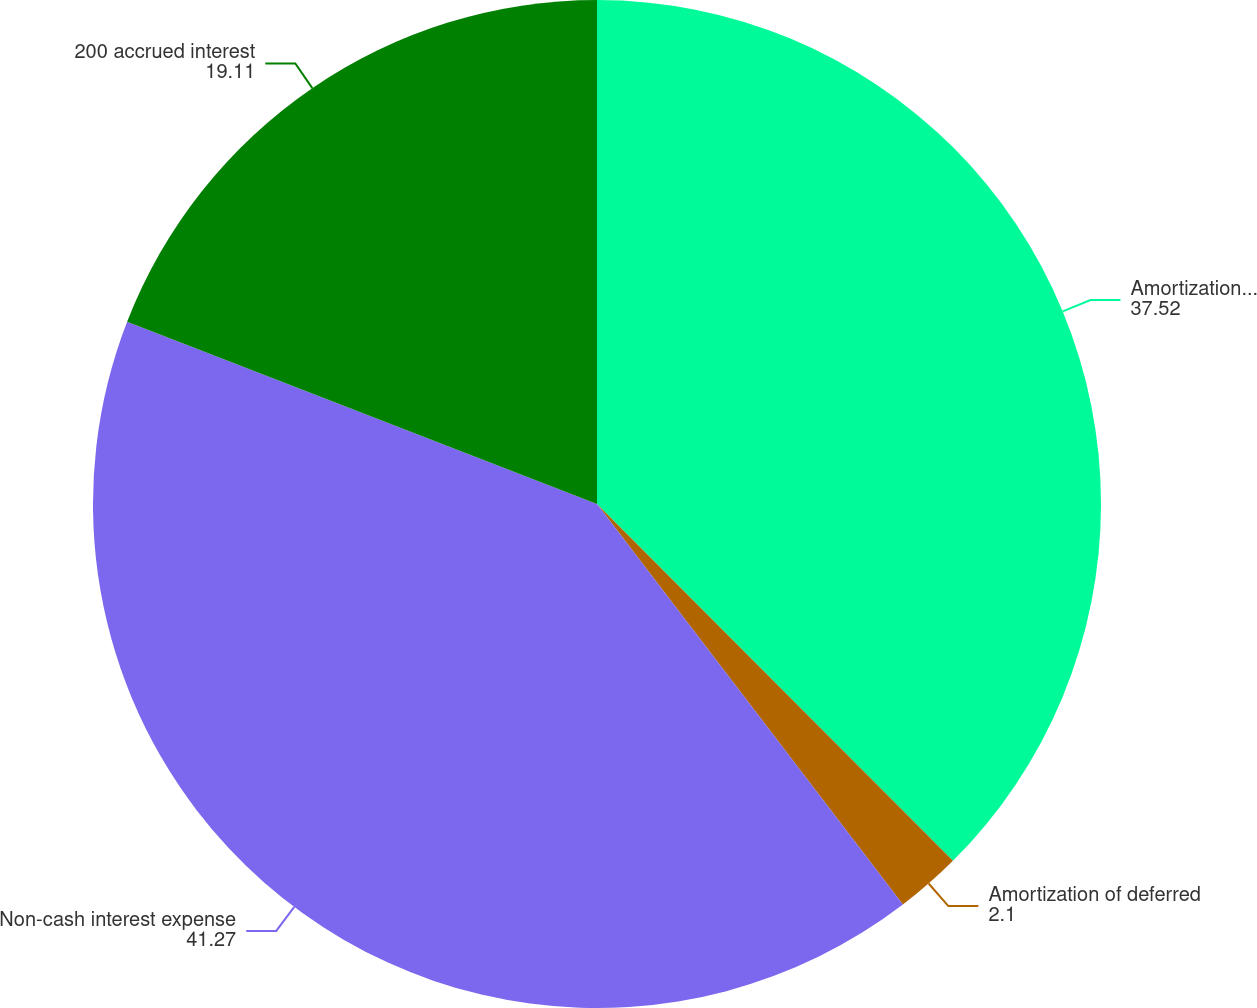Convert chart to OTSL. <chart><loc_0><loc_0><loc_500><loc_500><pie_chart><fcel>Amortization of debt discount<fcel>Amortization of deferred<fcel>Non-cash interest expense<fcel>200 accrued interest<nl><fcel>37.52%<fcel>2.1%<fcel>41.27%<fcel>19.11%<nl></chart> 